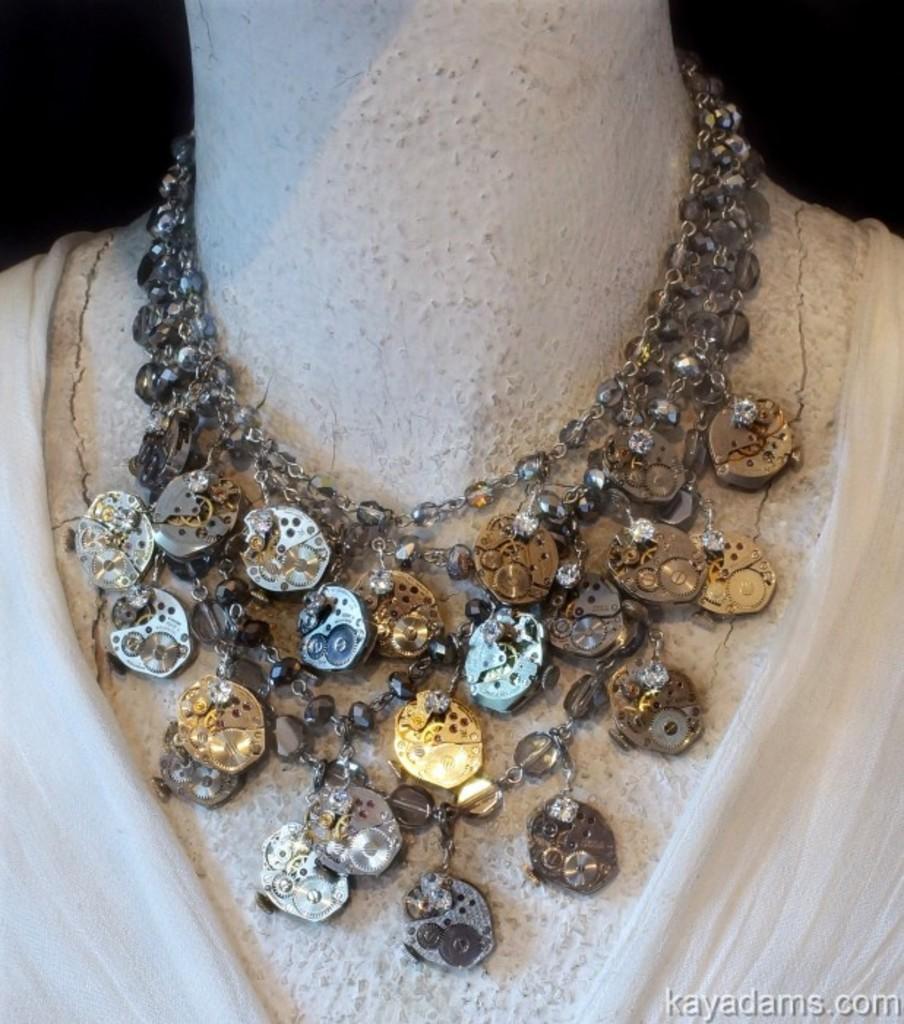Can you describe this image briefly? In the picture there is a necklace present to a mannequin. 